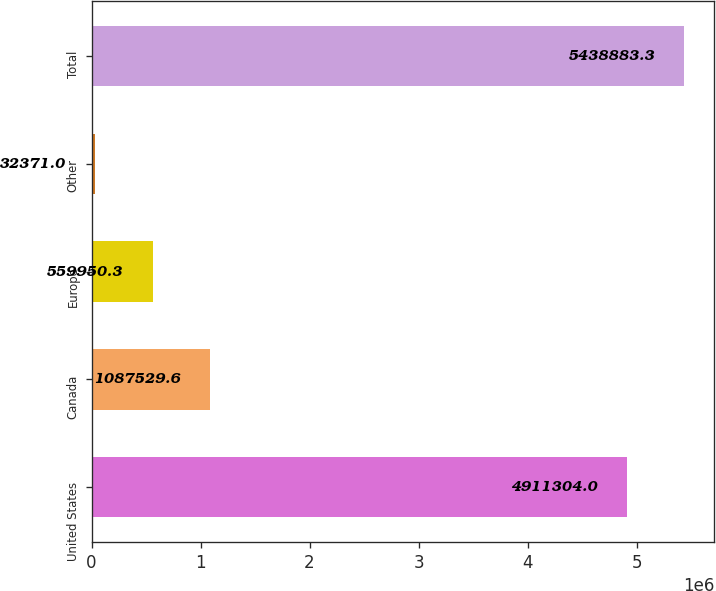<chart> <loc_0><loc_0><loc_500><loc_500><bar_chart><fcel>United States<fcel>Canada<fcel>Europe<fcel>Other<fcel>Total<nl><fcel>4.9113e+06<fcel>1.08753e+06<fcel>559950<fcel>32371<fcel>5.43888e+06<nl></chart> 